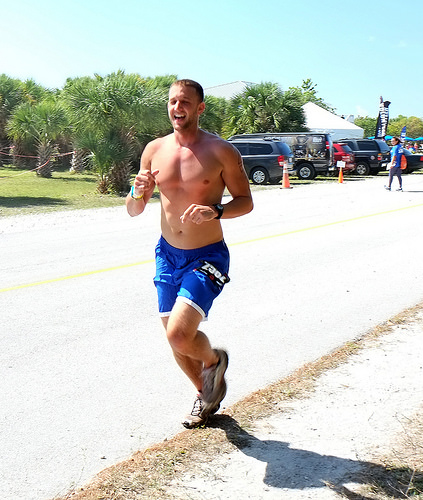<image>
Is there a cone behind the man? Yes. From this viewpoint, the cone is positioned behind the man, with the man partially or fully occluding the cone. 